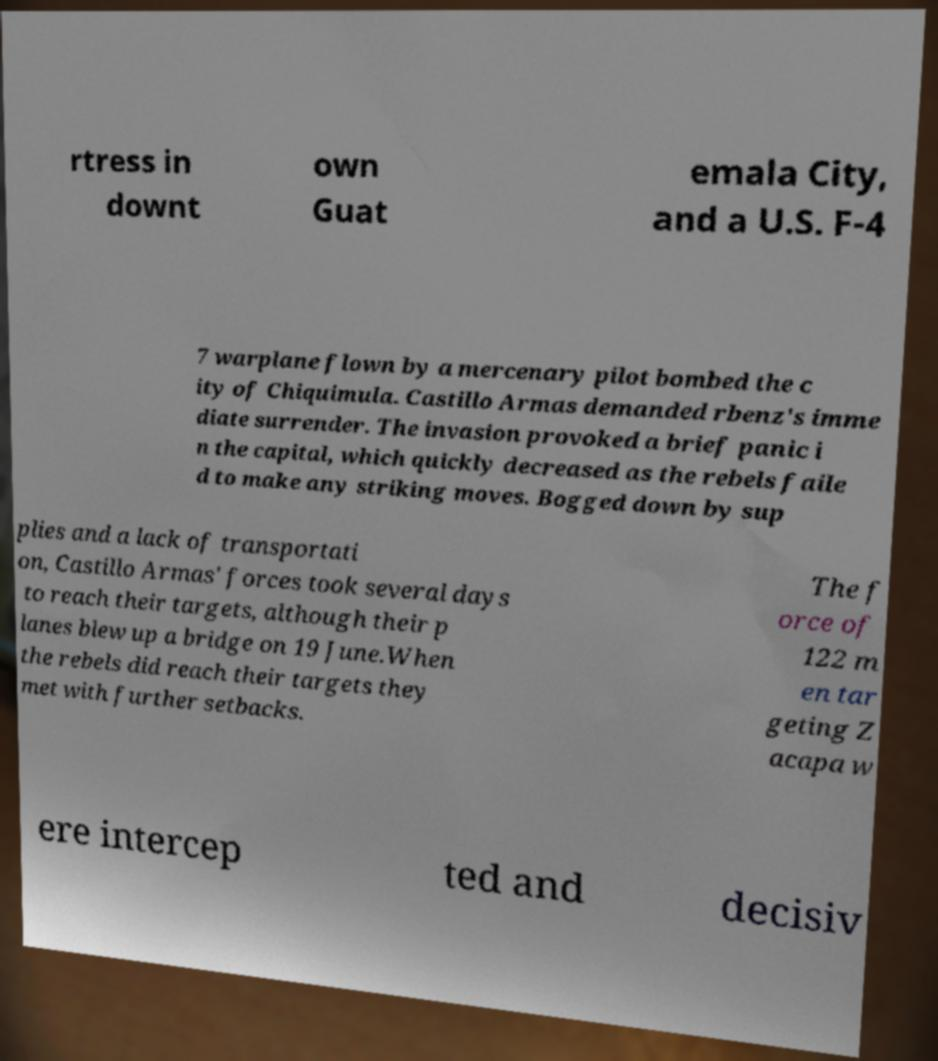There's text embedded in this image that I need extracted. Can you transcribe it verbatim? rtress in downt own Guat emala City, and a U.S. F-4 7 warplane flown by a mercenary pilot bombed the c ity of Chiquimula. Castillo Armas demanded rbenz's imme diate surrender. The invasion provoked a brief panic i n the capital, which quickly decreased as the rebels faile d to make any striking moves. Bogged down by sup plies and a lack of transportati on, Castillo Armas' forces took several days to reach their targets, although their p lanes blew up a bridge on 19 June.When the rebels did reach their targets they met with further setbacks. The f orce of 122 m en tar geting Z acapa w ere intercep ted and decisiv 